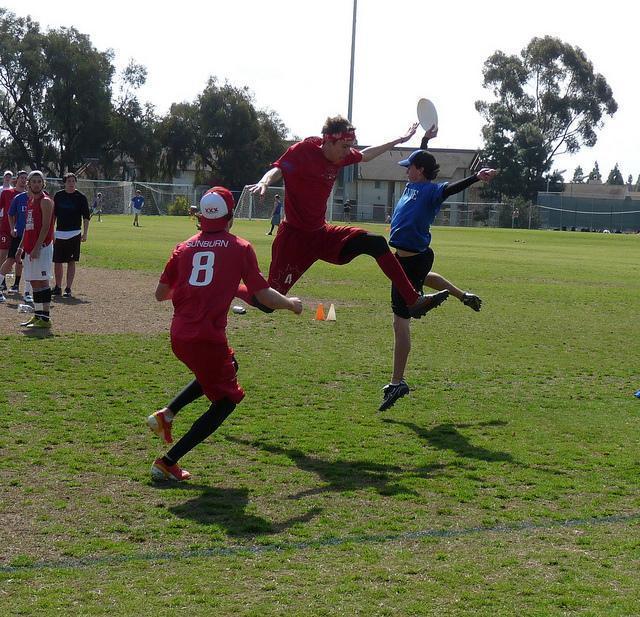What word rhymes with the number on the man's shirt?
Indicate the correct response and explain using: 'Answer: answer
Rationale: rationale.'
Options: Hate, boo, more, fine. Answer: hate.
Rationale: The word is hate. 